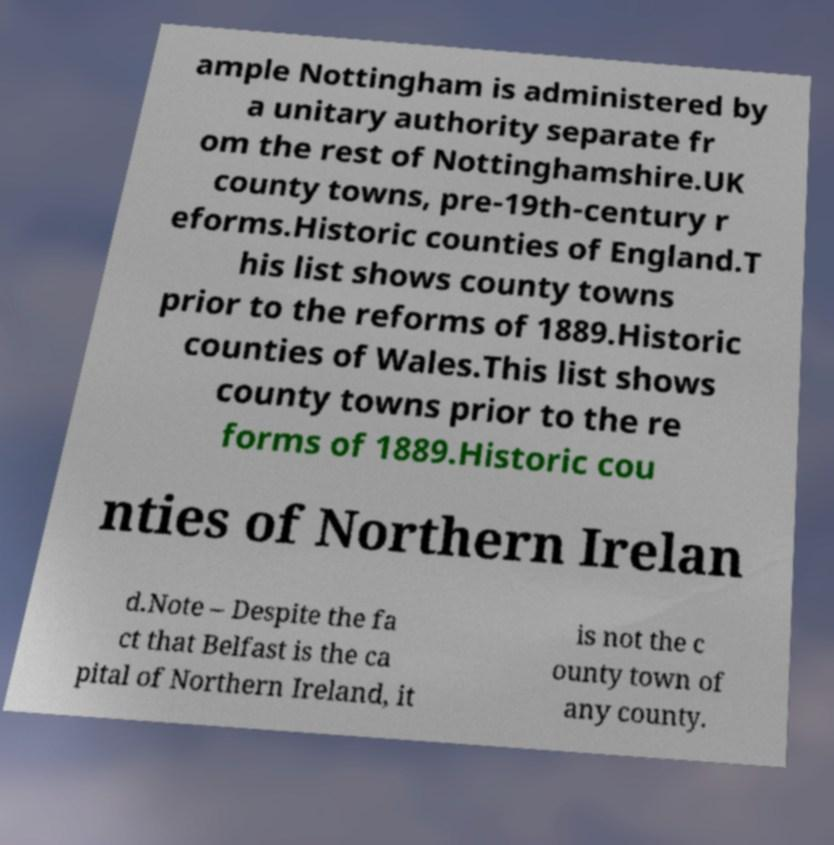Please identify and transcribe the text found in this image. ample Nottingham is administered by a unitary authority separate fr om the rest of Nottinghamshire.UK county towns, pre-19th-century r eforms.Historic counties of England.T his list shows county towns prior to the reforms of 1889.Historic counties of Wales.This list shows county towns prior to the re forms of 1889.Historic cou nties of Northern Irelan d.Note – Despite the fa ct that Belfast is the ca pital of Northern Ireland, it is not the c ounty town of any county. 